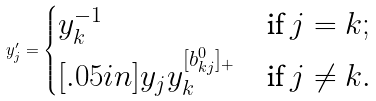<formula> <loc_0><loc_0><loc_500><loc_500>y ^ { \prime } _ { j } = \begin{cases} y _ { k } ^ { - 1 } & \text {if $j = k$} ; \\ [ . 0 5 i n ] y _ { j } y _ { k } ^ { [ b ^ { 0 } _ { k j } ] _ { + } } & \text {if $j \neq k$} . \end{cases}</formula> 